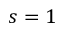Convert formula to latex. <formula><loc_0><loc_0><loc_500><loc_500>s = 1</formula> 